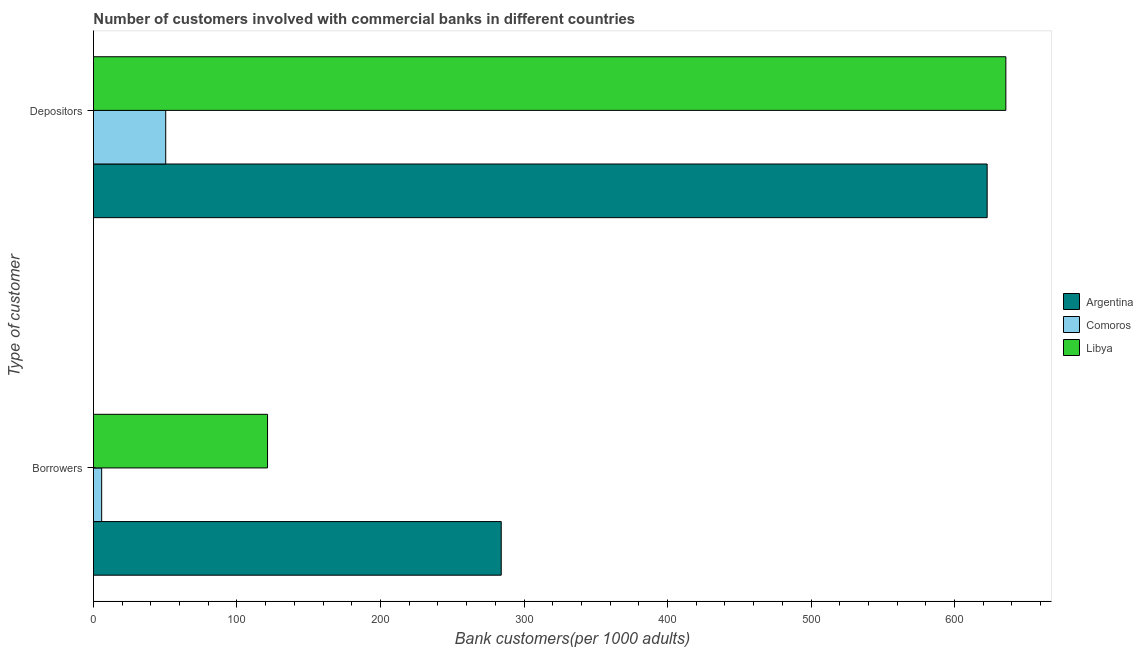Are the number of bars per tick equal to the number of legend labels?
Keep it short and to the point. Yes. Are the number of bars on each tick of the Y-axis equal?
Provide a succinct answer. Yes. What is the label of the 2nd group of bars from the top?
Your answer should be compact. Borrowers. What is the number of depositors in Libya?
Make the answer very short. 635.76. Across all countries, what is the maximum number of depositors?
Give a very brief answer. 635.76. Across all countries, what is the minimum number of borrowers?
Give a very brief answer. 5.73. In which country was the number of depositors minimum?
Offer a terse response. Comoros. What is the total number of borrowers in the graph?
Give a very brief answer. 411.17. What is the difference between the number of depositors in Comoros and that in Libya?
Make the answer very short. -585.41. What is the difference between the number of borrowers in Argentina and the number of depositors in Comoros?
Offer a terse response. 233.78. What is the average number of borrowers per country?
Provide a short and direct response. 137.06. What is the difference between the number of borrowers and number of depositors in Comoros?
Give a very brief answer. -44.63. In how many countries, is the number of depositors greater than 280 ?
Provide a succinct answer. 2. What is the ratio of the number of depositors in Argentina to that in Comoros?
Give a very brief answer. 12.37. Is the number of depositors in Libya less than that in Argentina?
Give a very brief answer. No. In how many countries, is the number of borrowers greater than the average number of borrowers taken over all countries?
Ensure brevity in your answer.  1. What does the 3rd bar from the top in Depositors represents?
Provide a succinct answer. Argentina. What does the 1st bar from the bottom in Depositors represents?
Offer a very short reply. Argentina. Are all the bars in the graph horizontal?
Give a very brief answer. Yes. How many countries are there in the graph?
Give a very brief answer. 3. Does the graph contain any zero values?
Your response must be concise. No. Where does the legend appear in the graph?
Your answer should be very brief. Center right. How many legend labels are there?
Ensure brevity in your answer.  3. What is the title of the graph?
Provide a succinct answer. Number of customers involved with commercial banks in different countries. Does "Malawi" appear as one of the legend labels in the graph?
Your response must be concise. No. What is the label or title of the X-axis?
Provide a short and direct response. Bank customers(per 1000 adults). What is the label or title of the Y-axis?
Provide a succinct answer. Type of customer. What is the Bank customers(per 1000 adults) of Argentina in Borrowers?
Your answer should be very brief. 284.14. What is the Bank customers(per 1000 adults) in Comoros in Borrowers?
Offer a very short reply. 5.73. What is the Bank customers(per 1000 adults) of Libya in Borrowers?
Your answer should be compact. 121.31. What is the Bank customers(per 1000 adults) in Argentina in Depositors?
Keep it short and to the point. 622.73. What is the Bank customers(per 1000 adults) in Comoros in Depositors?
Offer a very short reply. 50.36. What is the Bank customers(per 1000 adults) in Libya in Depositors?
Your answer should be very brief. 635.76. Across all Type of customer, what is the maximum Bank customers(per 1000 adults) in Argentina?
Give a very brief answer. 622.73. Across all Type of customer, what is the maximum Bank customers(per 1000 adults) of Comoros?
Your answer should be very brief. 50.36. Across all Type of customer, what is the maximum Bank customers(per 1000 adults) of Libya?
Offer a terse response. 635.76. Across all Type of customer, what is the minimum Bank customers(per 1000 adults) in Argentina?
Your answer should be compact. 284.14. Across all Type of customer, what is the minimum Bank customers(per 1000 adults) of Comoros?
Offer a terse response. 5.73. Across all Type of customer, what is the minimum Bank customers(per 1000 adults) in Libya?
Provide a short and direct response. 121.31. What is the total Bank customers(per 1000 adults) of Argentina in the graph?
Offer a very short reply. 906.87. What is the total Bank customers(per 1000 adults) in Comoros in the graph?
Your answer should be very brief. 56.08. What is the total Bank customers(per 1000 adults) of Libya in the graph?
Give a very brief answer. 757.07. What is the difference between the Bank customers(per 1000 adults) in Argentina in Borrowers and that in Depositors?
Make the answer very short. -338.6. What is the difference between the Bank customers(per 1000 adults) of Comoros in Borrowers and that in Depositors?
Make the answer very short. -44.63. What is the difference between the Bank customers(per 1000 adults) of Libya in Borrowers and that in Depositors?
Make the answer very short. -514.45. What is the difference between the Bank customers(per 1000 adults) of Argentina in Borrowers and the Bank customers(per 1000 adults) of Comoros in Depositors?
Offer a very short reply. 233.78. What is the difference between the Bank customers(per 1000 adults) of Argentina in Borrowers and the Bank customers(per 1000 adults) of Libya in Depositors?
Offer a very short reply. -351.62. What is the difference between the Bank customers(per 1000 adults) of Comoros in Borrowers and the Bank customers(per 1000 adults) of Libya in Depositors?
Ensure brevity in your answer.  -630.04. What is the average Bank customers(per 1000 adults) of Argentina per Type of customer?
Give a very brief answer. 453.43. What is the average Bank customers(per 1000 adults) in Comoros per Type of customer?
Keep it short and to the point. 28.04. What is the average Bank customers(per 1000 adults) of Libya per Type of customer?
Give a very brief answer. 378.53. What is the difference between the Bank customers(per 1000 adults) of Argentina and Bank customers(per 1000 adults) of Comoros in Borrowers?
Your answer should be compact. 278.41. What is the difference between the Bank customers(per 1000 adults) in Argentina and Bank customers(per 1000 adults) in Libya in Borrowers?
Your answer should be compact. 162.83. What is the difference between the Bank customers(per 1000 adults) of Comoros and Bank customers(per 1000 adults) of Libya in Borrowers?
Your answer should be compact. -115.58. What is the difference between the Bank customers(per 1000 adults) of Argentina and Bank customers(per 1000 adults) of Comoros in Depositors?
Keep it short and to the point. 572.38. What is the difference between the Bank customers(per 1000 adults) of Argentina and Bank customers(per 1000 adults) of Libya in Depositors?
Ensure brevity in your answer.  -13.03. What is the difference between the Bank customers(per 1000 adults) of Comoros and Bank customers(per 1000 adults) of Libya in Depositors?
Make the answer very short. -585.41. What is the ratio of the Bank customers(per 1000 adults) in Argentina in Borrowers to that in Depositors?
Offer a very short reply. 0.46. What is the ratio of the Bank customers(per 1000 adults) of Comoros in Borrowers to that in Depositors?
Your response must be concise. 0.11. What is the ratio of the Bank customers(per 1000 adults) in Libya in Borrowers to that in Depositors?
Ensure brevity in your answer.  0.19. What is the difference between the highest and the second highest Bank customers(per 1000 adults) of Argentina?
Offer a very short reply. 338.6. What is the difference between the highest and the second highest Bank customers(per 1000 adults) of Comoros?
Offer a very short reply. 44.63. What is the difference between the highest and the second highest Bank customers(per 1000 adults) of Libya?
Offer a terse response. 514.45. What is the difference between the highest and the lowest Bank customers(per 1000 adults) in Argentina?
Your response must be concise. 338.6. What is the difference between the highest and the lowest Bank customers(per 1000 adults) in Comoros?
Offer a very short reply. 44.63. What is the difference between the highest and the lowest Bank customers(per 1000 adults) of Libya?
Keep it short and to the point. 514.45. 